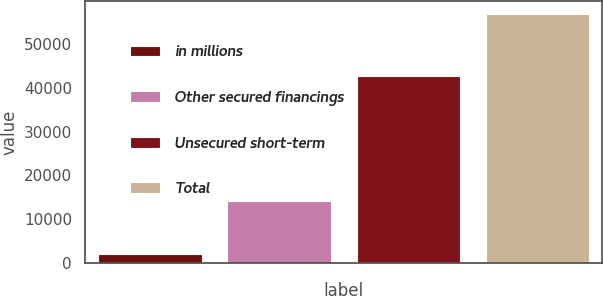<chart> <loc_0><loc_0><loc_500><loc_500><bar_chart><fcel>in millions<fcel>Other secured financings<fcel>Unsecured short-term<fcel>Total<nl><fcel>2015<fcel>14233<fcel>42787<fcel>57020<nl></chart> 